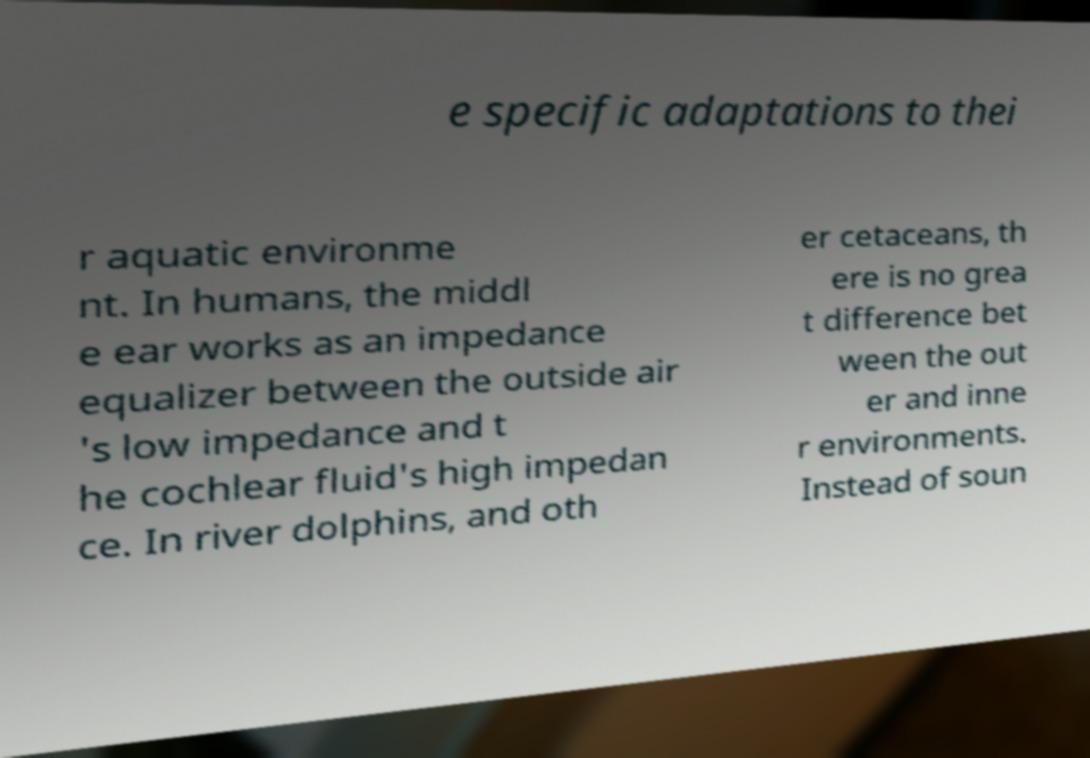Can you read and provide the text displayed in the image?This photo seems to have some interesting text. Can you extract and type it out for me? e specific adaptations to thei r aquatic environme nt. In humans, the middl e ear works as an impedance equalizer between the outside air 's low impedance and t he cochlear fluid's high impedan ce. In river dolphins, and oth er cetaceans, th ere is no grea t difference bet ween the out er and inne r environments. Instead of soun 